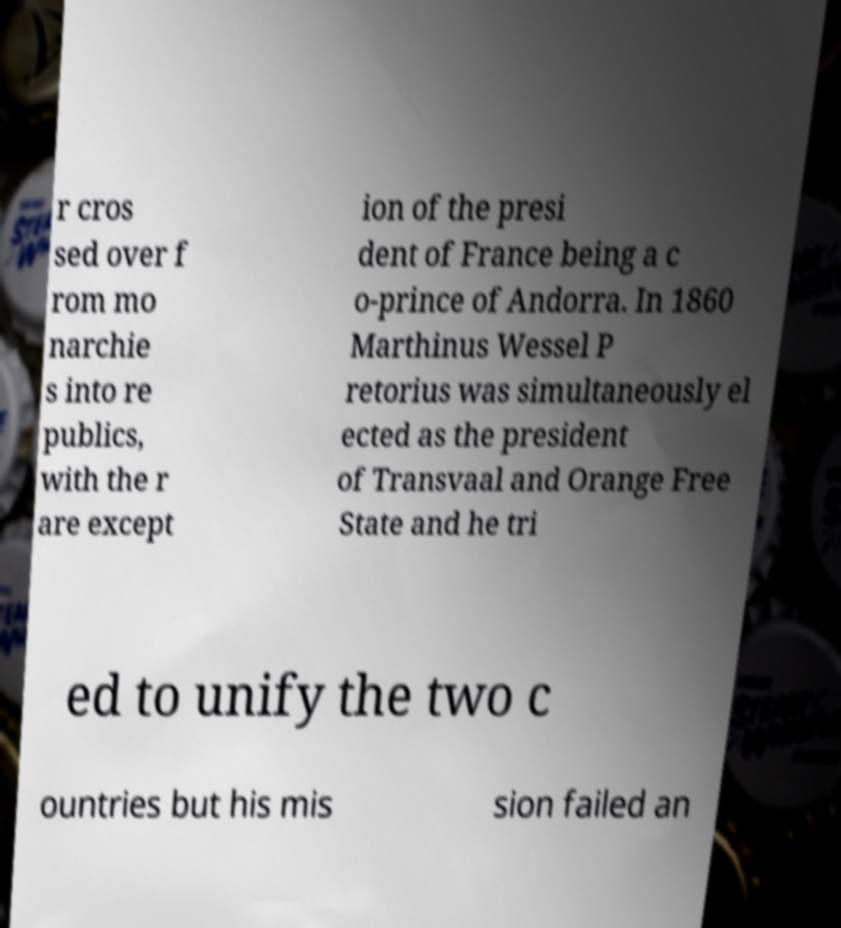Can you read and provide the text displayed in the image?This photo seems to have some interesting text. Can you extract and type it out for me? r cros sed over f rom mo narchie s into re publics, with the r are except ion of the presi dent of France being a c o-prince of Andorra. In 1860 Marthinus Wessel P retorius was simultaneously el ected as the president of Transvaal and Orange Free State and he tri ed to unify the two c ountries but his mis sion failed an 